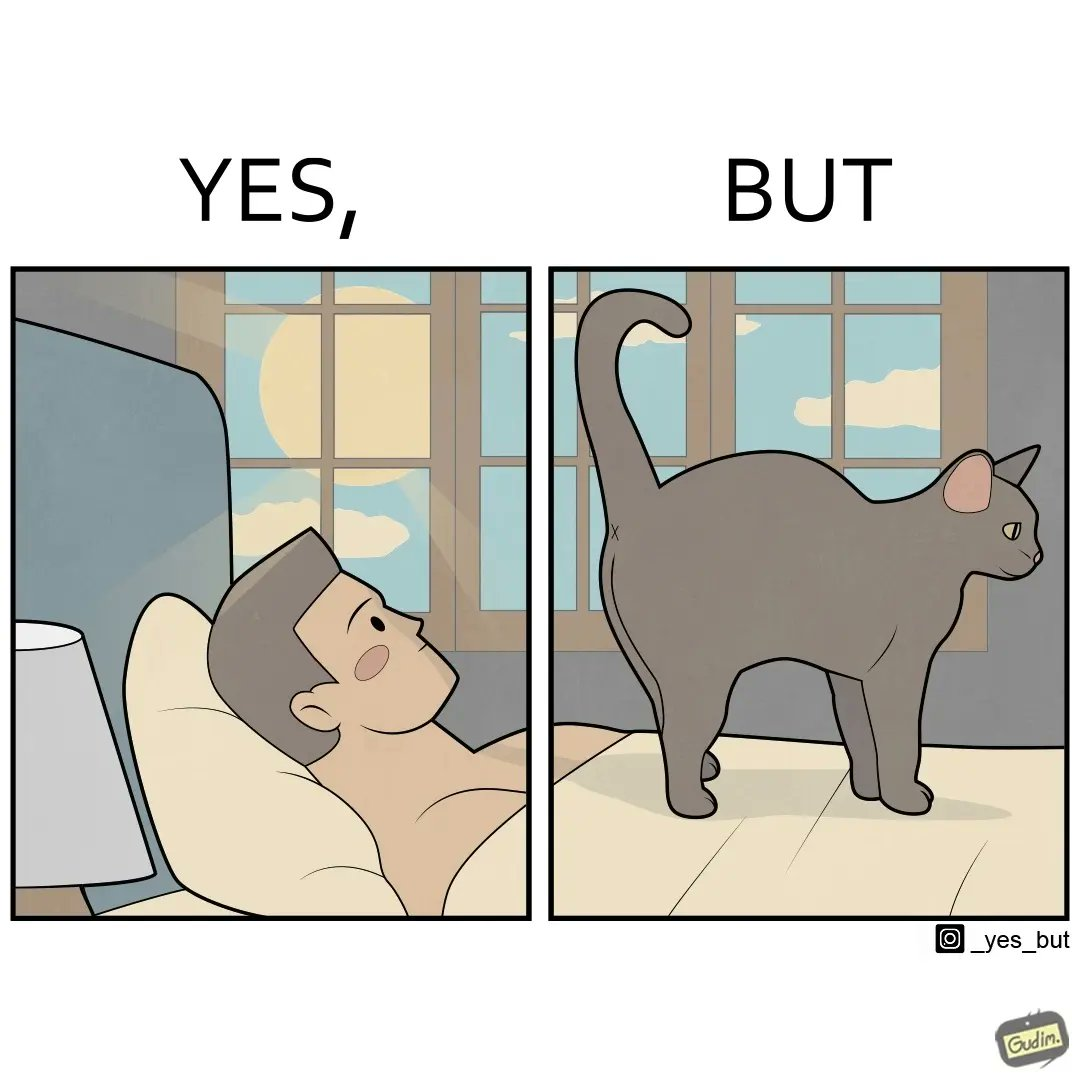What do you see in each half of this image? In the left part of the image: a person with his opens in his bed, probably waking up from sleep In the right part of the image: a cat at some high platform standing and gazing at something 